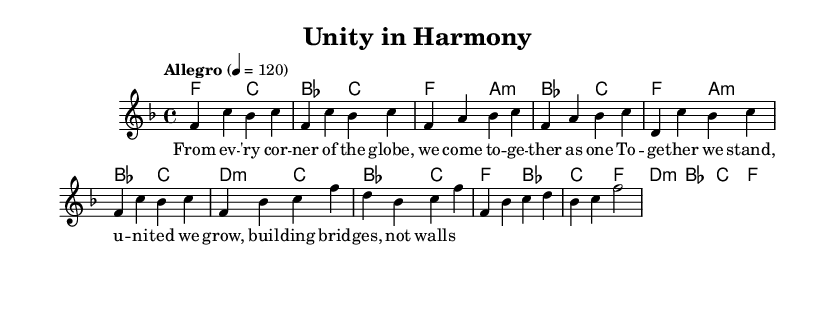What is the key signature of this music? The key signature is F major, which includes one flat (B flat). This is determined by looking for any sharps or flats indicated at the beginning of the staff.
Answer: F major What is the time signature of this music? The time signature is 4/4, which means there are four beats per measure and the quarter note gets one beat. This is usually indicated at the beginning of the staff with the two numbers stacked on top of each other.
Answer: 4/4 What is the tempo marking of this piece? The tempo marking is "Allegro", which indicates a fast and lively tempo. This is found at the beginning of the sheet music, showing the desired speed for the piece.
Answer: Allegro How many measures are there in the chorus? There are four measures in the chorus section. By counting the distinct parts of the music where the melody is sung, the segments dedicated to the chorus can be identified.
Answer: 4 What is the overall theme of the lyrics in this song? The overall theme of the lyrics is unity and cooperation among diverse groups of people. The use of words like "together" and "building bridges, not walls" emphasizes this message, which can be inferred from both the verse and chorus lyrics.
Answer: Unity What is the chord progression for the first verse? The chord progression for the first verse is F, A minor, B flat, C. This can be determined by identifying the chords associated with each measure within the verse segment of the sheet music.
Answer: F, A minor, B flat, C What style of music is represented by this sheet? The style of music is Soul, characterized by its emotional expression and a focus on themes of diversity and community. This is inferred from both the musical elements and the lyrical content celebrating international cooperation.
Answer: Soul 